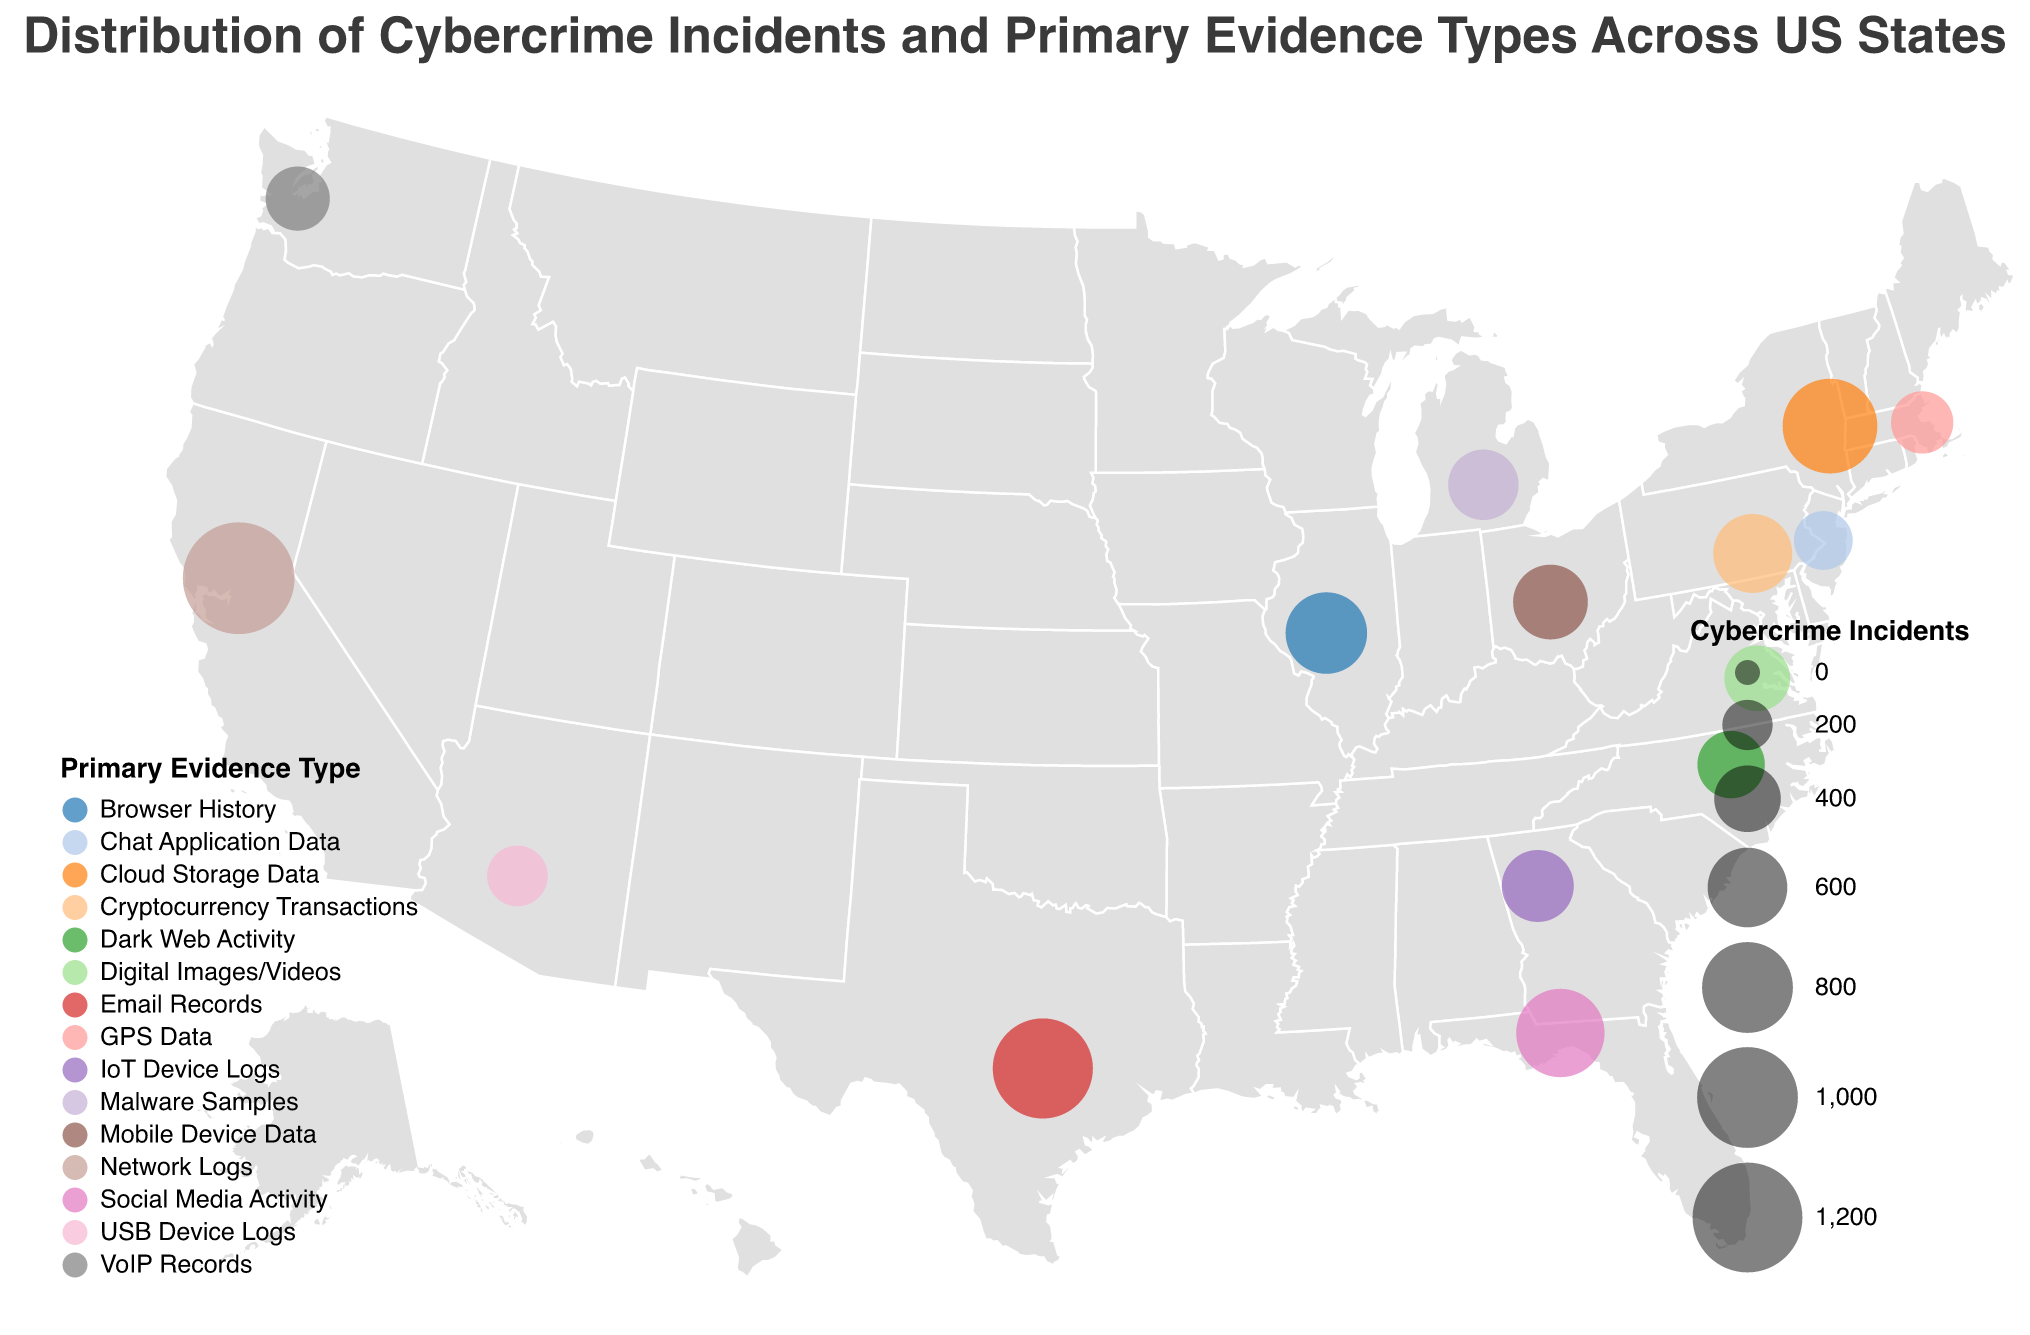What's the total number of cybercrime incidents across all the states? To find the total number of cybercrime incidents, sum the incidents from each state: 1245 + 987 + 876 + 754 + 632 + 589 + 521 + 478 + 456 + 412 + 389 + 367 + 342 + 321 + 298
Answer: 8667 Which state has the highest number of cybercrime incidents? By comparing the cybercrime incidents across all states, California has the highest number with 1245 incidents
Answer: California What is the primary evidence type for cybercrime incidents in Texas? The figure indicates that the primary evidence type in Texas is Email Records
Answer: Email Records Compare the cybercrime incidents between California and New York. Which state has more incidents and by how much? California has 1245 incidents, and New York has 876. Subtracting these: 1245 - 876 = 369. Thus, California has 369 more incidents than New York
Answer: California, 369 What is the most common primary evidence type for states with fewer than 500 incidents? Looking at states with fewer than 500 incidents: Georgia, Michigan, North Carolina, Virginia, Washington, Massachusetts, Arizona, and New Jersey, we see the primary evidence types as IoT Device Logs, Malware Samples, Dark Web Activity, Digital Images/Videos, VoIP Records, GPS Data, USB Device Logs, and Chat Application Data, respectively. No single type is repeated, so there's no 'most common' type
Answer: No most common type Which states primarily collect Network Logs as digital forensic evidence? Among the states listed, California is the state where Network Logs are the primary evidence type
Answer: California What is the average number of cybercrime incidents across all states? To find the average, divide the total number of incidents (8667) by the number of states (15): 8667 / 15 ≈ 577.8
Answer: 577.8 Which state has the least number of cybercrime incidents, and what is the primary evidence type there? New Jersey has the least number of incidents with 298, and the primary evidence type is Chat Application Data
Answer: New Jersey, Chat Application Data How many states have more than 600 cybercrime incidents? States with more than 600 incidents are California (1245), Texas (987), New York (876), Florida (754), and Illinois (632). There are 5 states in total
Answer: 5 Do any two states share the same primary evidence type, and if so, which type and states? Looking through the data, no two states share the same primary evidence type. Each state has a unique evidence type
Answer: No 